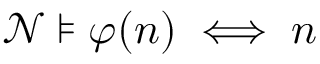Convert formula to latex. <formula><loc_0><loc_0><loc_500><loc_500>{ \mathcal { N } } \models \varphi ( n ) \iff n</formula> 